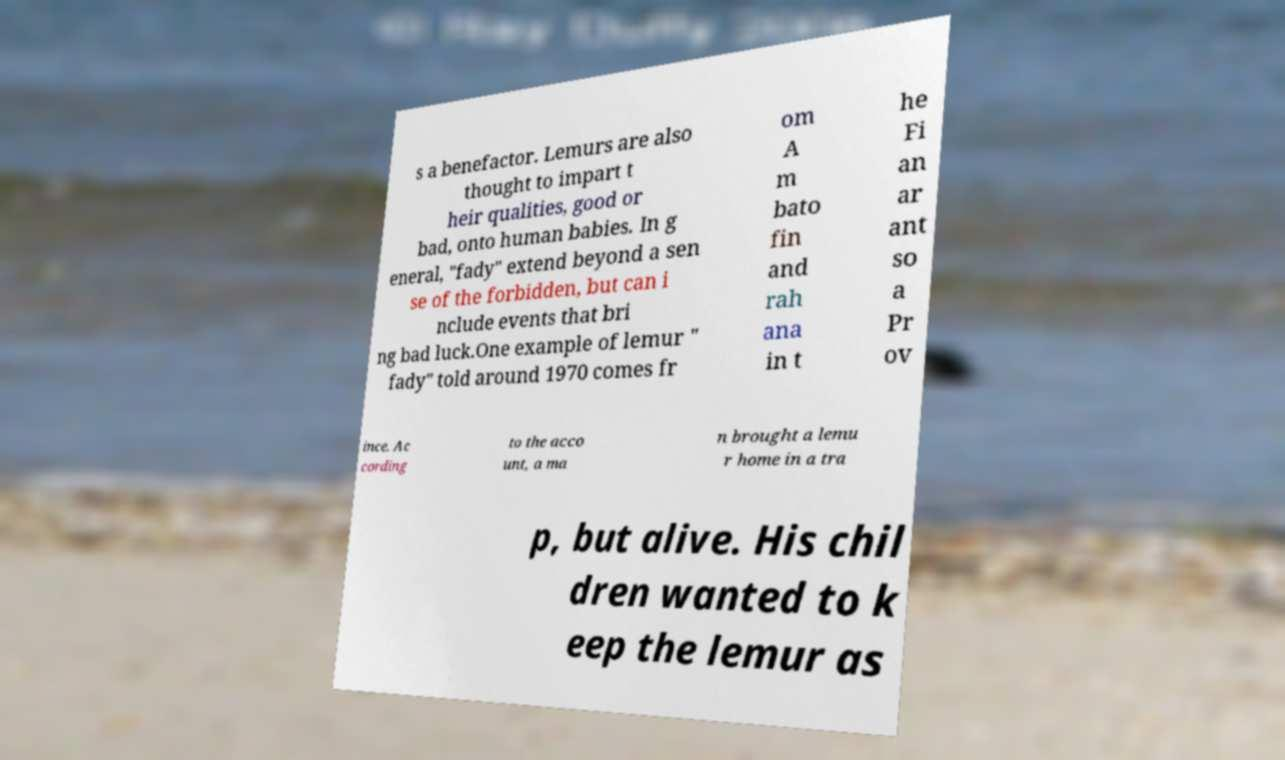Can you read and provide the text displayed in the image?This photo seems to have some interesting text. Can you extract and type it out for me? s a benefactor. Lemurs are also thought to impart t heir qualities, good or bad, onto human babies. In g eneral, "fady" extend beyond a sen se of the forbidden, but can i nclude events that bri ng bad luck.One example of lemur " fady" told around 1970 comes fr om A m bato fin and rah ana in t he Fi an ar ant so a Pr ov ince. Ac cording to the acco unt, a ma n brought a lemu r home in a tra p, but alive. His chil dren wanted to k eep the lemur as 